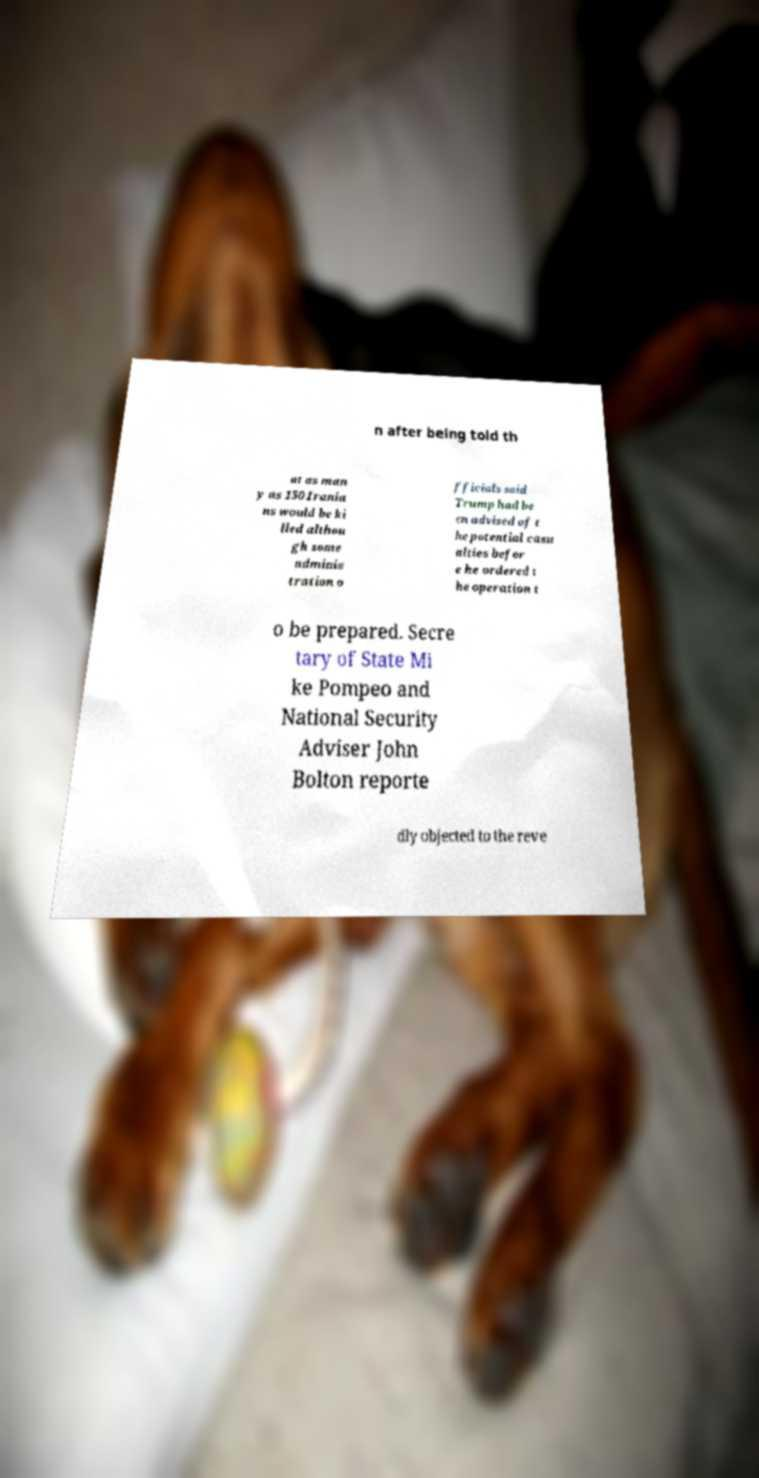There's text embedded in this image that I need extracted. Can you transcribe it verbatim? n after being told th at as man y as 150 Irania ns would be ki lled althou gh some adminis tration o fficials said Trump had be en advised of t he potential casu alties befor e he ordered t he operation t o be prepared. Secre tary of State Mi ke Pompeo and National Security Adviser John Bolton reporte dly objected to the reve 